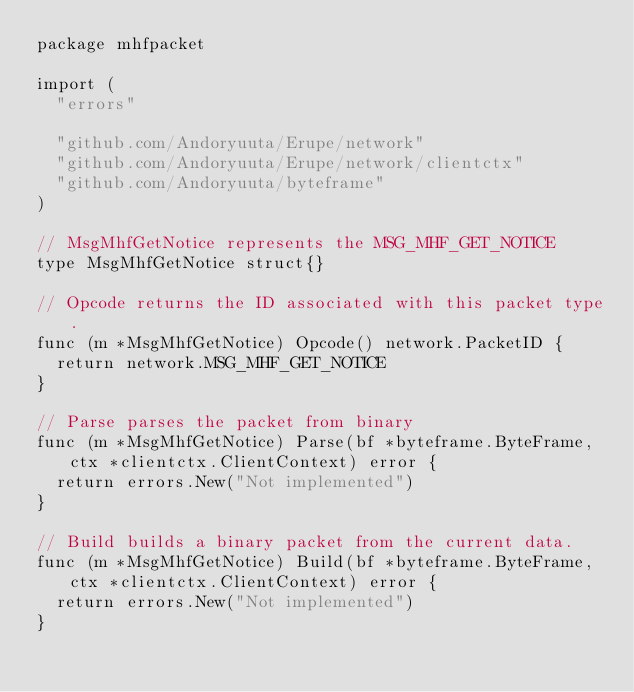Convert code to text. <code><loc_0><loc_0><loc_500><loc_500><_Go_>package mhfpacket

import (
	"errors"

	"github.com/Andoryuuta/Erupe/network"
	"github.com/Andoryuuta/Erupe/network/clientctx"
	"github.com/Andoryuuta/byteframe"
)

// MsgMhfGetNotice represents the MSG_MHF_GET_NOTICE
type MsgMhfGetNotice struct{}

// Opcode returns the ID associated with this packet type.
func (m *MsgMhfGetNotice) Opcode() network.PacketID {
	return network.MSG_MHF_GET_NOTICE
}

// Parse parses the packet from binary
func (m *MsgMhfGetNotice) Parse(bf *byteframe.ByteFrame, ctx *clientctx.ClientContext) error {
	return errors.New("Not implemented")
}

// Build builds a binary packet from the current data.
func (m *MsgMhfGetNotice) Build(bf *byteframe.ByteFrame, ctx *clientctx.ClientContext) error {
	return errors.New("Not implemented")
}
</code> 